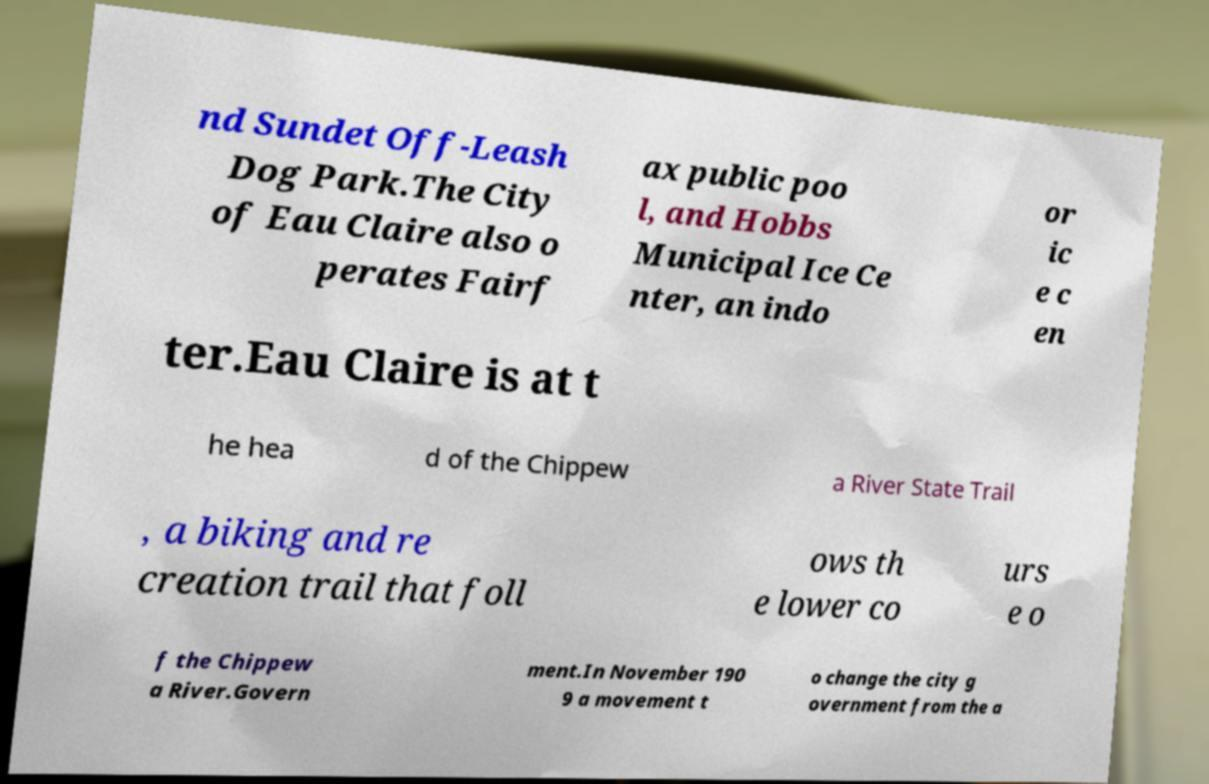I need the written content from this picture converted into text. Can you do that? nd Sundet Off-Leash Dog Park.The City of Eau Claire also o perates Fairf ax public poo l, and Hobbs Municipal Ice Ce nter, an indo or ic e c en ter.Eau Claire is at t he hea d of the Chippew a River State Trail , a biking and re creation trail that foll ows th e lower co urs e o f the Chippew a River.Govern ment.In November 190 9 a movement t o change the city g overnment from the a 